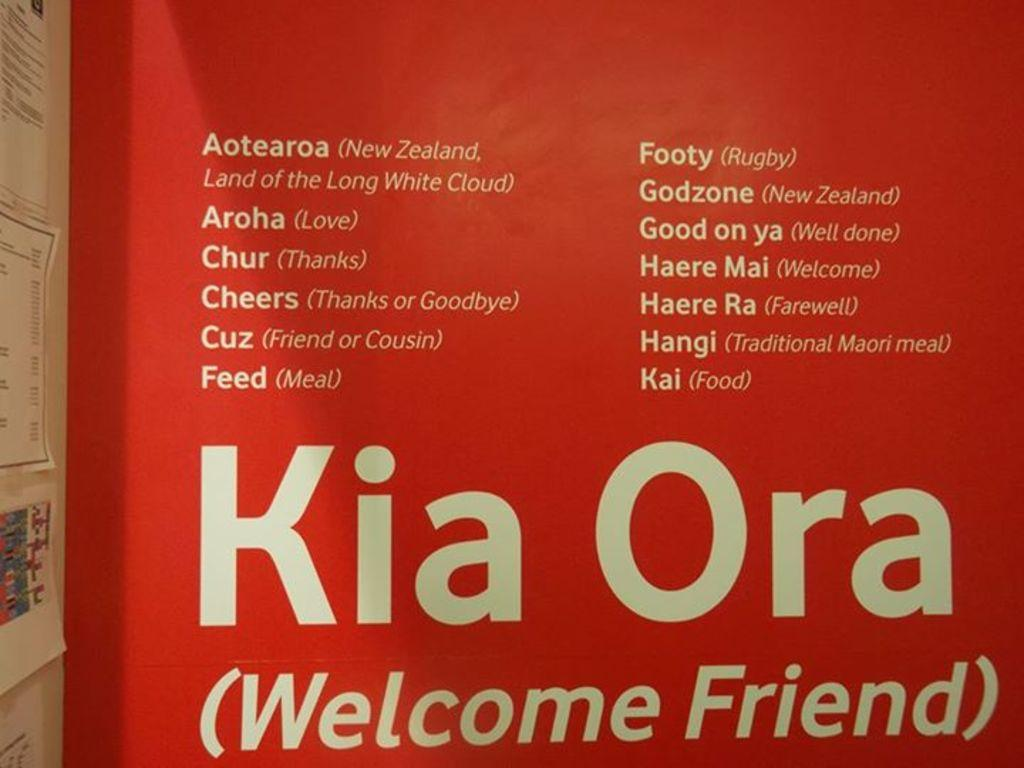<image>
Share a concise interpretation of the image provided. Sign telling you that Kia Ora means welcome friend. 